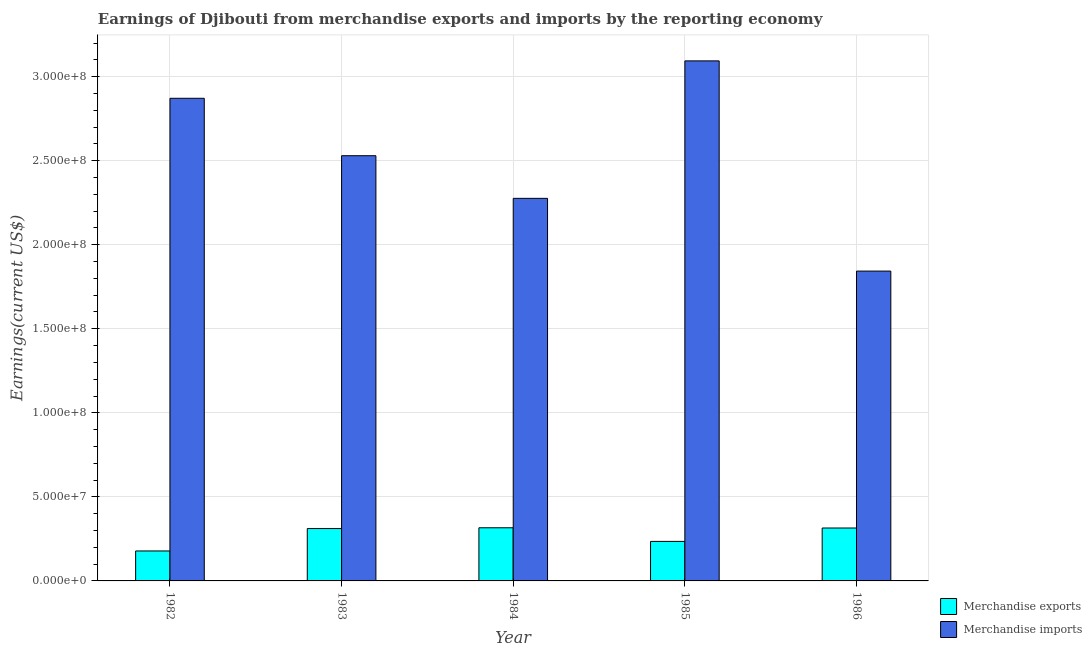How many different coloured bars are there?
Your response must be concise. 2. How many groups of bars are there?
Provide a short and direct response. 5. How many bars are there on the 1st tick from the left?
Provide a succinct answer. 2. In how many cases, is the number of bars for a given year not equal to the number of legend labels?
Your response must be concise. 0. What is the earnings from merchandise imports in 1986?
Keep it short and to the point. 1.84e+08. Across all years, what is the maximum earnings from merchandise imports?
Your answer should be very brief. 3.09e+08. Across all years, what is the minimum earnings from merchandise imports?
Provide a succinct answer. 1.84e+08. In which year was the earnings from merchandise imports maximum?
Provide a short and direct response. 1985. In which year was the earnings from merchandise imports minimum?
Your answer should be compact. 1986. What is the total earnings from merchandise imports in the graph?
Offer a terse response. 1.26e+09. What is the difference between the earnings from merchandise imports in 1982 and that in 1986?
Keep it short and to the point. 1.03e+08. What is the difference between the earnings from merchandise exports in 1986 and the earnings from merchandise imports in 1983?
Ensure brevity in your answer.  3.24e+05. What is the average earnings from merchandise imports per year?
Give a very brief answer. 2.52e+08. What is the ratio of the earnings from merchandise imports in 1982 to that in 1986?
Make the answer very short. 1.56. Is the earnings from merchandise imports in 1983 less than that in 1985?
Keep it short and to the point. Yes. Is the difference between the earnings from merchandise imports in 1983 and 1985 greater than the difference between the earnings from merchandise exports in 1983 and 1985?
Make the answer very short. No. What is the difference between the highest and the second highest earnings from merchandise imports?
Ensure brevity in your answer.  2.23e+07. What is the difference between the highest and the lowest earnings from merchandise exports?
Provide a short and direct response. 1.38e+07. What does the 2nd bar from the left in 1986 represents?
Your answer should be very brief. Merchandise imports. What does the 2nd bar from the right in 1983 represents?
Make the answer very short. Merchandise exports. How many bars are there?
Offer a terse response. 10. Are all the bars in the graph horizontal?
Keep it short and to the point. No. How many years are there in the graph?
Keep it short and to the point. 5. What is the difference between two consecutive major ticks on the Y-axis?
Keep it short and to the point. 5.00e+07. How many legend labels are there?
Your answer should be very brief. 2. What is the title of the graph?
Offer a very short reply. Earnings of Djibouti from merchandise exports and imports by the reporting economy. Does "Under-five" appear as one of the legend labels in the graph?
Your answer should be very brief. No. What is the label or title of the X-axis?
Offer a terse response. Year. What is the label or title of the Y-axis?
Keep it short and to the point. Earnings(current US$). What is the Earnings(current US$) of Merchandise exports in 1982?
Your answer should be compact. 1.78e+07. What is the Earnings(current US$) in Merchandise imports in 1982?
Provide a succinct answer. 2.87e+08. What is the Earnings(current US$) of Merchandise exports in 1983?
Offer a terse response. 3.12e+07. What is the Earnings(current US$) in Merchandise imports in 1983?
Give a very brief answer. 2.53e+08. What is the Earnings(current US$) of Merchandise exports in 1984?
Offer a very short reply. 3.16e+07. What is the Earnings(current US$) in Merchandise imports in 1984?
Your response must be concise. 2.28e+08. What is the Earnings(current US$) in Merchandise exports in 1985?
Give a very brief answer. 2.35e+07. What is the Earnings(current US$) in Merchandise imports in 1985?
Offer a terse response. 3.09e+08. What is the Earnings(current US$) of Merchandise exports in 1986?
Your answer should be very brief. 3.15e+07. What is the Earnings(current US$) of Merchandise imports in 1986?
Ensure brevity in your answer.  1.84e+08. Across all years, what is the maximum Earnings(current US$) in Merchandise exports?
Offer a terse response. 3.16e+07. Across all years, what is the maximum Earnings(current US$) in Merchandise imports?
Your response must be concise. 3.09e+08. Across all years, what is the minimum Earnings(current US$) of Merchandise exports?
Provide a succinct answer. 1.78e+07. Across all years, what is the minimum Earnings(current US$) of Merchandise imports?
Give a very brief answer. 1.84e+08. What is the total Earnings(current US$) in Merchandise exports in the graph?
Your answer should be very brief. 1.36e+08. What is the total Earnings(current US$) of Merchandise imports in the graph?
Ensure brevity in your answer.  1.26e+09. What is the difference between the Earnings(current US$) of Merchandise exports in 1982 and that in 1983?
Provide a short and direct response. -1.33e+07. What is the difference between the Earnings(current US$) in Merchandise imports in 1982 and that in 1983?
Keep it short and to the point. 3.42e+07. What is the difference between the Earnings(current US$) in Merchandise exports in 1982 and that in 1984?
Give a very brief answer. -1.38e+07. What is the difference between the Earnings(current US$) of Merchandise imports in 1982 and that in 1984?
Give a very brief answer. 5.95e+07. What is the difference between the Earnings(current US$) in Merchandise exports in 1982 and that in 1985?
Make the answer very short. -5.69e+06. What is the difference between the Earnings(current US$) of Merchandise imports in 1982 and that in 1985?
Keep it short and to the point. -2.23e+07. What is the difference between the Earnings(current US$) in Merchandise exports in 1982 and that in 1986?
Your answer should be very brief. -1.37e+07. What is the difference between the Earnings(current US$) of Merchandise imports in 1982 and that in 1986?
Offer a terse response. 1.03e+08. What is the difference between the Earnings(current US$) in Merchandise exports in 1983 and that in 1984?
Your response must be concise. -4.61e+05. What is the difference between the Earnings(current US$) of Merchandise imports in 1983 and that in 1984?
Make the answer very short. 2.54e+07. What is the difference between the Earnings(current US$) of Merchandise exports in 1983 and that in 1985?
Make the answer very short. 7.65e+06. What is the difference between the Earnings(current US$) of Merchandise imports in 1983 and that in 1985?
Your answer should be very brief. -5.64e+07. What is the difference between the Earnings(current US$) in Merchandise exports in 1983 and that in 1986?
Provide a succinct answer. -3.24e+05. What is the difference between the Earnings(current US$) of Merchandise imports in 1983 and that in 1986?
Offer a terse response. 6.86e+07. What is the difference between the Earnings(current US$) of Merchandise exports in 1984 and that in 1985?
Ensure brevity in your answer.  8.11e+06. What is the difference between the Earnings(current US$) in Merchandise imports in 1984 and that in 1985?
Offer a terse response. -8.18e+07. What is the difference between the Earnings(current US$) of Merchandise exports in 1984 and that in 1986?
Your answer should be compact. 1.37e+05. What is the difference between the Earnings(current US$) of Merchandise imports in 1984 and that in 1986?
Your answer should be very brief. 4.33e+07. What is the difference between the Earnings(current US$) in Merchandise exports in 1985 and that in 1986?
Offer a very short reply. -7.97e+06. What is the difference between the Earnings(current US$) of Merchandise imports in 1985 and that in 1986?
Give a very brief answer. 1.25e+08. What is the difference between the Earnings(current US$) of Merchandise exports in 1982 and the Earnings(current US$) of Merchandise imports in 1983?
Offer a very short reply. -2.35e+08. What is the difference between the Earnings(current US$) of Merchandise exports in 1982 and the Earnings(current US$) of Merchandise imports in 1984?
Your answer should be compact. -2.10e+08. What is the difference between the Earnings(current US$) of Merchandise exports in 1982 and the Earnings(current US$) of Merchandise imports in 1985?
Your answer should be compact. -2.92e+08. What is the difference between the Earnings(current US$) of Merchandise exports in 1982 and the Earnings(current US$) of Merchandise imports in 1986?
Provide a succinct answer. -1.67e+08. What is the difference between the Earnings(current US$) of Merchandise exports in 1983 and the Earnings(current US$) of Merchandise imports in 1984?
Give a very brief answer. -1.96e+08. What is the difference between the Earnings(current US$) in Merchandise exports in 1983 and the Earnings(current US$) in Merchandise imports in 1985?
Ensure brevity in your answer.  -2.78e+08. What is the difference between the Earnings(current US$) of Merchandise exports in 1983 and the Earnings(current US$) of Merchandise imports in 1986?
Ensure brevity in your answer.  -1.53e+08. What is the difference between the Earnings(current US$) of Merchandise exports in 1984 and the Earnings(current US$) of Merchandise imports in 1985?
Your answer should be compact. -2.78e+08. What is the difference between the Earnings(current US$) in Merchandise exports in 1984 and the Earnings(current US$) in Merchandise imports in 1986?
Make the answer very short. -1.53e+08. What is the difference between the Earnings(current US$) in Merchandise exports in 1985 and the Earnings(current US$) in Merchandise imports in 1986?
Provide a succinct answer. -1.61e+08. What is the average Earnings(current US$) of Merchandise exports per year?
Make the answer very short. 2.71e+07. What is the average Earnings(current US$) of Merchandise imports per year?
Offer a terse response. 2.52e+08. In the year 1982, what is the difference between the Earnings(current US$) in Merchandise exports and Earnings(current US$) in Merchandise imports?
Make the answer very short. -2.69e+08. In the year 1983, what is the difference between the Earnings(current US$) in Merchandise exports and Earnings(current US$) in Merchandise imports?
Your answer should be very brief. -2.22e+08. In the year 1984, what is the difference between the Earnings(current US$) in Merchandise exports and Earnings(current US$) in Merchandise imports?
Offer a terse response. -1.96e+08. In the year 1985, what is the difference between the Earnings(current US$) in Merchandise exports and Earnings(current US$) in Merchandise imports?
Offer a very short reply. -2.86e+08. In the year 1986, what is the difference between the Earnings(current US$) in Merchandise exports and Earnings(current US$) in Merchandise imports?
Keep it short and to the point. -1.53e+08. What is the ratio of the Earnings(current US$) in Merchandise exports in 1982 to that in 1983?
Offer a very short reply. 0.57. What is the ratio of the Earnings(current US$) of Merchandise imports in 1982 to that in 1983?
Your answer should be very brief. 1.14. What is the ratio of the Earnings(current US$) in Merchandise exports in 1982 to that in 1984?
Provide a succinct answer. 0.56. What is the ratio of the Earnings(current US$) in Merchandise imports in 1982 to that in 1984?
Provide a short and direct response. 1.26. What is the ratio of the Earnings(current US$) in Merchandise exports in 1982 to that in 1985?
Offer a very short reply. 0.76. What is the ratio of the Earnings(current US$) in Merchandise imports in 1982 to that in 1985?
Keep it short and to the point. 0.93. What is the ratio of the Earnings(current US$) of Merchandise exports in 1982 to that in 1986?
Ensure brevity in your answer.  0.57. What is the ratio of the Earnings(current US$) of Merchandise imports in 1982 to that in 1986?
Make the answer very short. 1.56. What is the ratio of the Earnings(current US$) of Merchandise exports in 1983 to that in 1984?
Offer a terse response. 0.99. What is the ratio of the Earnings(current US$) in Merchandise imports in 1983 to that in 1984?
Your answer should be compact. 1.11. What is the ratio of the Earnings(current US$) of Merchandise exports in 1983 to that in 1985?
Keep it short and to the point. 1.33. What is the ratio of the Earnings(current US$) of Merchandise imports in 1983 to that in 1985?
Keep it short and to the point. 0.82. What is the ratio of the Earnings(current US$) of Merchandise imports in 1983 to that in 1986?
Your response must be concise. 1.37. What is the ratio of the Earnings(current US$) in Merchandise exports in 1984 to that in 1985?
Provide a succinct answer. 1.34. What is the ratio of the Earnings(current US$) of Merchandise imports in 1984 to that in 1985?
Offer a very short reply. 0.74. What is the ratio of the Earnings(current US$) in Merchandise imports in 1984 to that in 1986?
Make the answer very short. 1.23. What is the ratio of the Earnings(current US$) of Merchandise exports in 1985 to that in 1986?
Offer a very short reply. 0.75. What is the ratio of the Earnings(current US$) of Merchandise imports in 1985 to that in 1986?
Your answer should be compact. 1.68. What is the difference between the highest and the second highest Earnings(current US$) of Merchandise exports?
Offer a terse response. 1.37e+05. What is the difference between the highest and the second highest Earnings(current US$) of Merchandise imports?
Ensure brevity in your answer.  2.23e+07. What is the difference between the highest and the lowest Earnings(current US$) of Merchandise exports?
Make the answer very short. 1.38e+07. What is the difference between the highest and the lowest Earnings(current US$) in Merchandise imports?
Provide a short and direct response. 1.25e+08. 